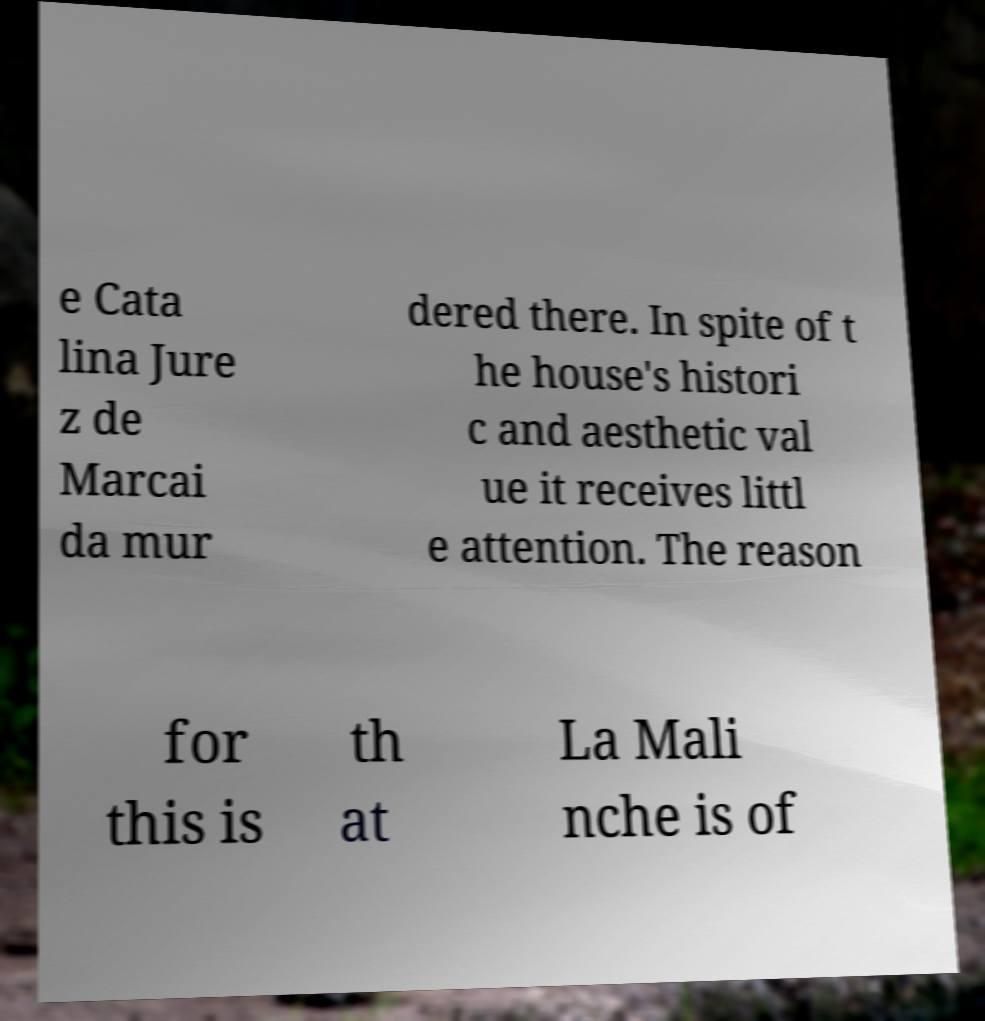Please identify and transcribe the text found in this image. e Cata lina Jure z de Marcai da mur dered there. In spite of t he house's histori c and aesthetic val ue it receives littl e attention. The reason for this is th at La Mali nche is of 